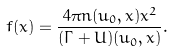<formula> <loc_0><loc_0><loc_500><loc_500>f ( x ) = \frac { 4 \pi n ( u _ { 0 } , x ) x ^ { 2 } } { ( \Gamma + U ) ( u _ { 0 } , x ) } .</formula> 